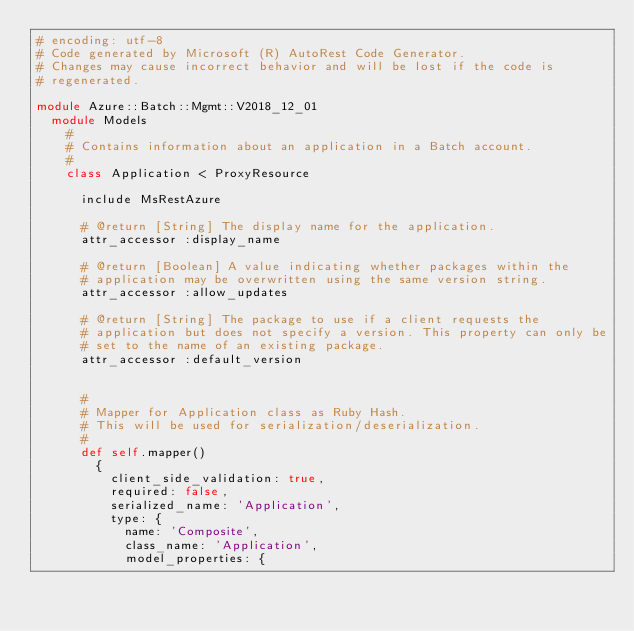<code> <loc_0><loc_0><loc_500><loc_500><_Ruby_># encoding: utf-8
# Code generated by Microsoft (R) AutoRest Code Generator.
# Changes may cause incorrect behavior and will be lost if the code is
# regenerated.

module Azure::Batch::Mgmt::V2018_12_01
  module Models
    #
    # Contains information about an application in a Batch account.
    #
    class Application < ProxyResource

      include MsRestAzure

      # @return [String] The display name for the application.
      attr_accessor :display_name

      # @return [Boolean] A value indicating whether packages within the
      # application may be overwritten using the same version string.
      attr_accessor :allow_updates

      # @return [String] The package to use if a client requests the
      # application but does not specify a version. This property can only be
      # set to the name of an existing package.
      attr_accessor :default_version


      #
      # Mapper for Application class as Ruby Hash.
      # This will be used for serialization/deserialization.
      #
      def self.mapper()
        {
          client_side_validation: true,
          required: false,
          serialized_name: 'Application',
          type: {
            name: 'Composite',
            class_name: 'Application',
            model_properties: {</code> 